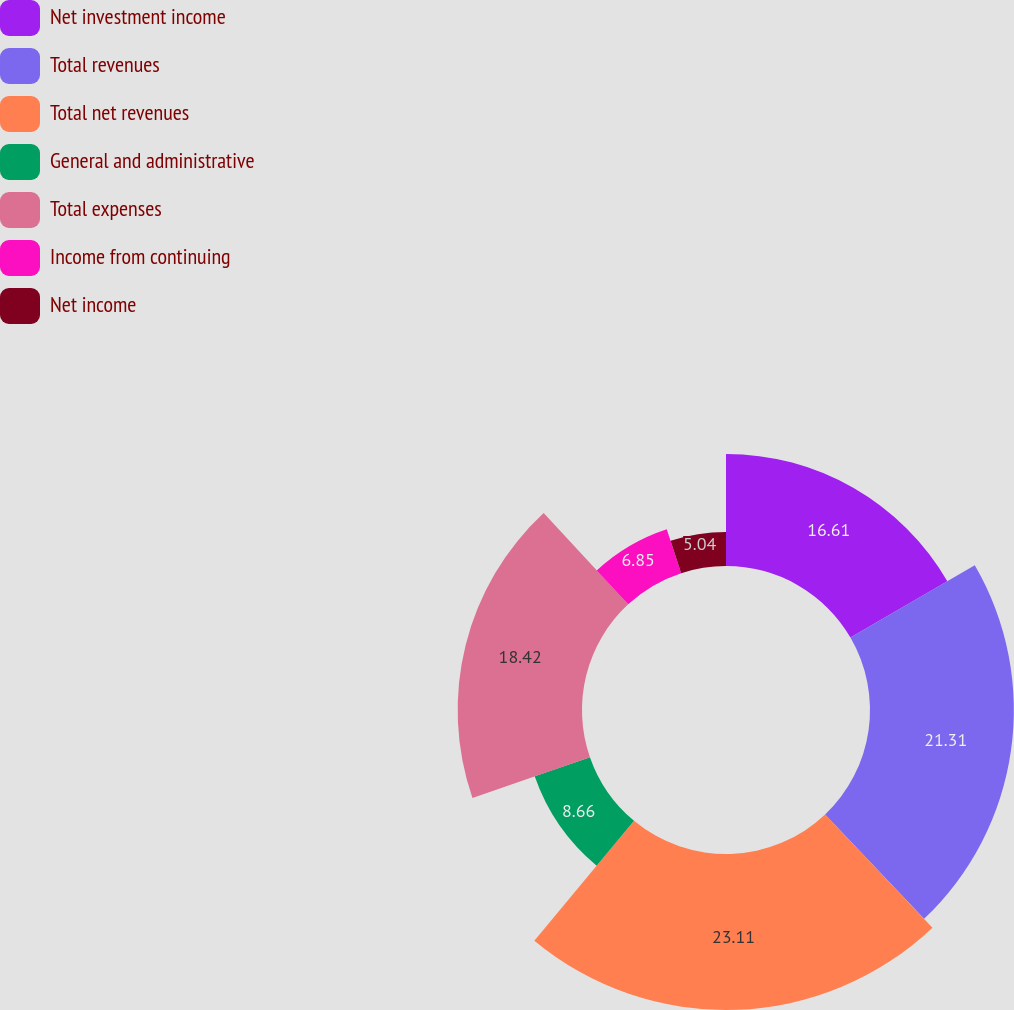Convert chart to OTSL. <chart><loc_0><loc_0><loc_500><loc_500><pie_chart><fcel>Net investment income<fcel>Total revenues<fcel>Total net revenues<fcel>General and administrative<fcel>Total expenses<fcel>Income from continuing<fcel>Net income<nl><fcel>16.61%<fcel>21.31%<fcel>23.11%<fcel>8.66%<fcel>18.42%<fcel>6.85%<fcel>5.04%<nl></chart> 